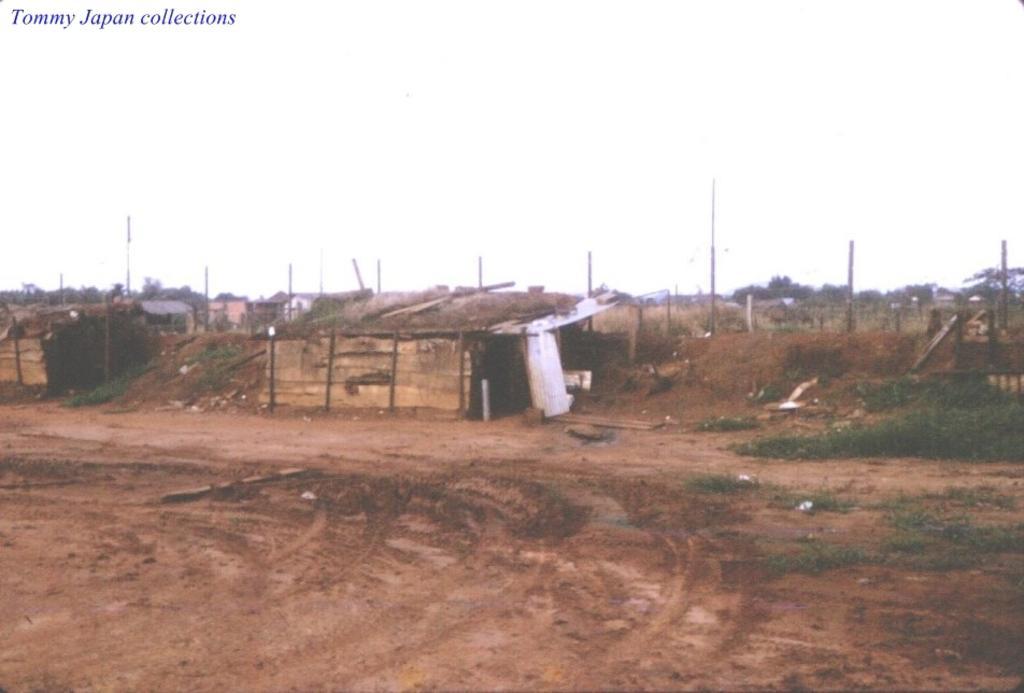Could you give a brief overview of what you see in this image? In this image we can see sheds, poles, fence, ground, grass, trees and sky. 